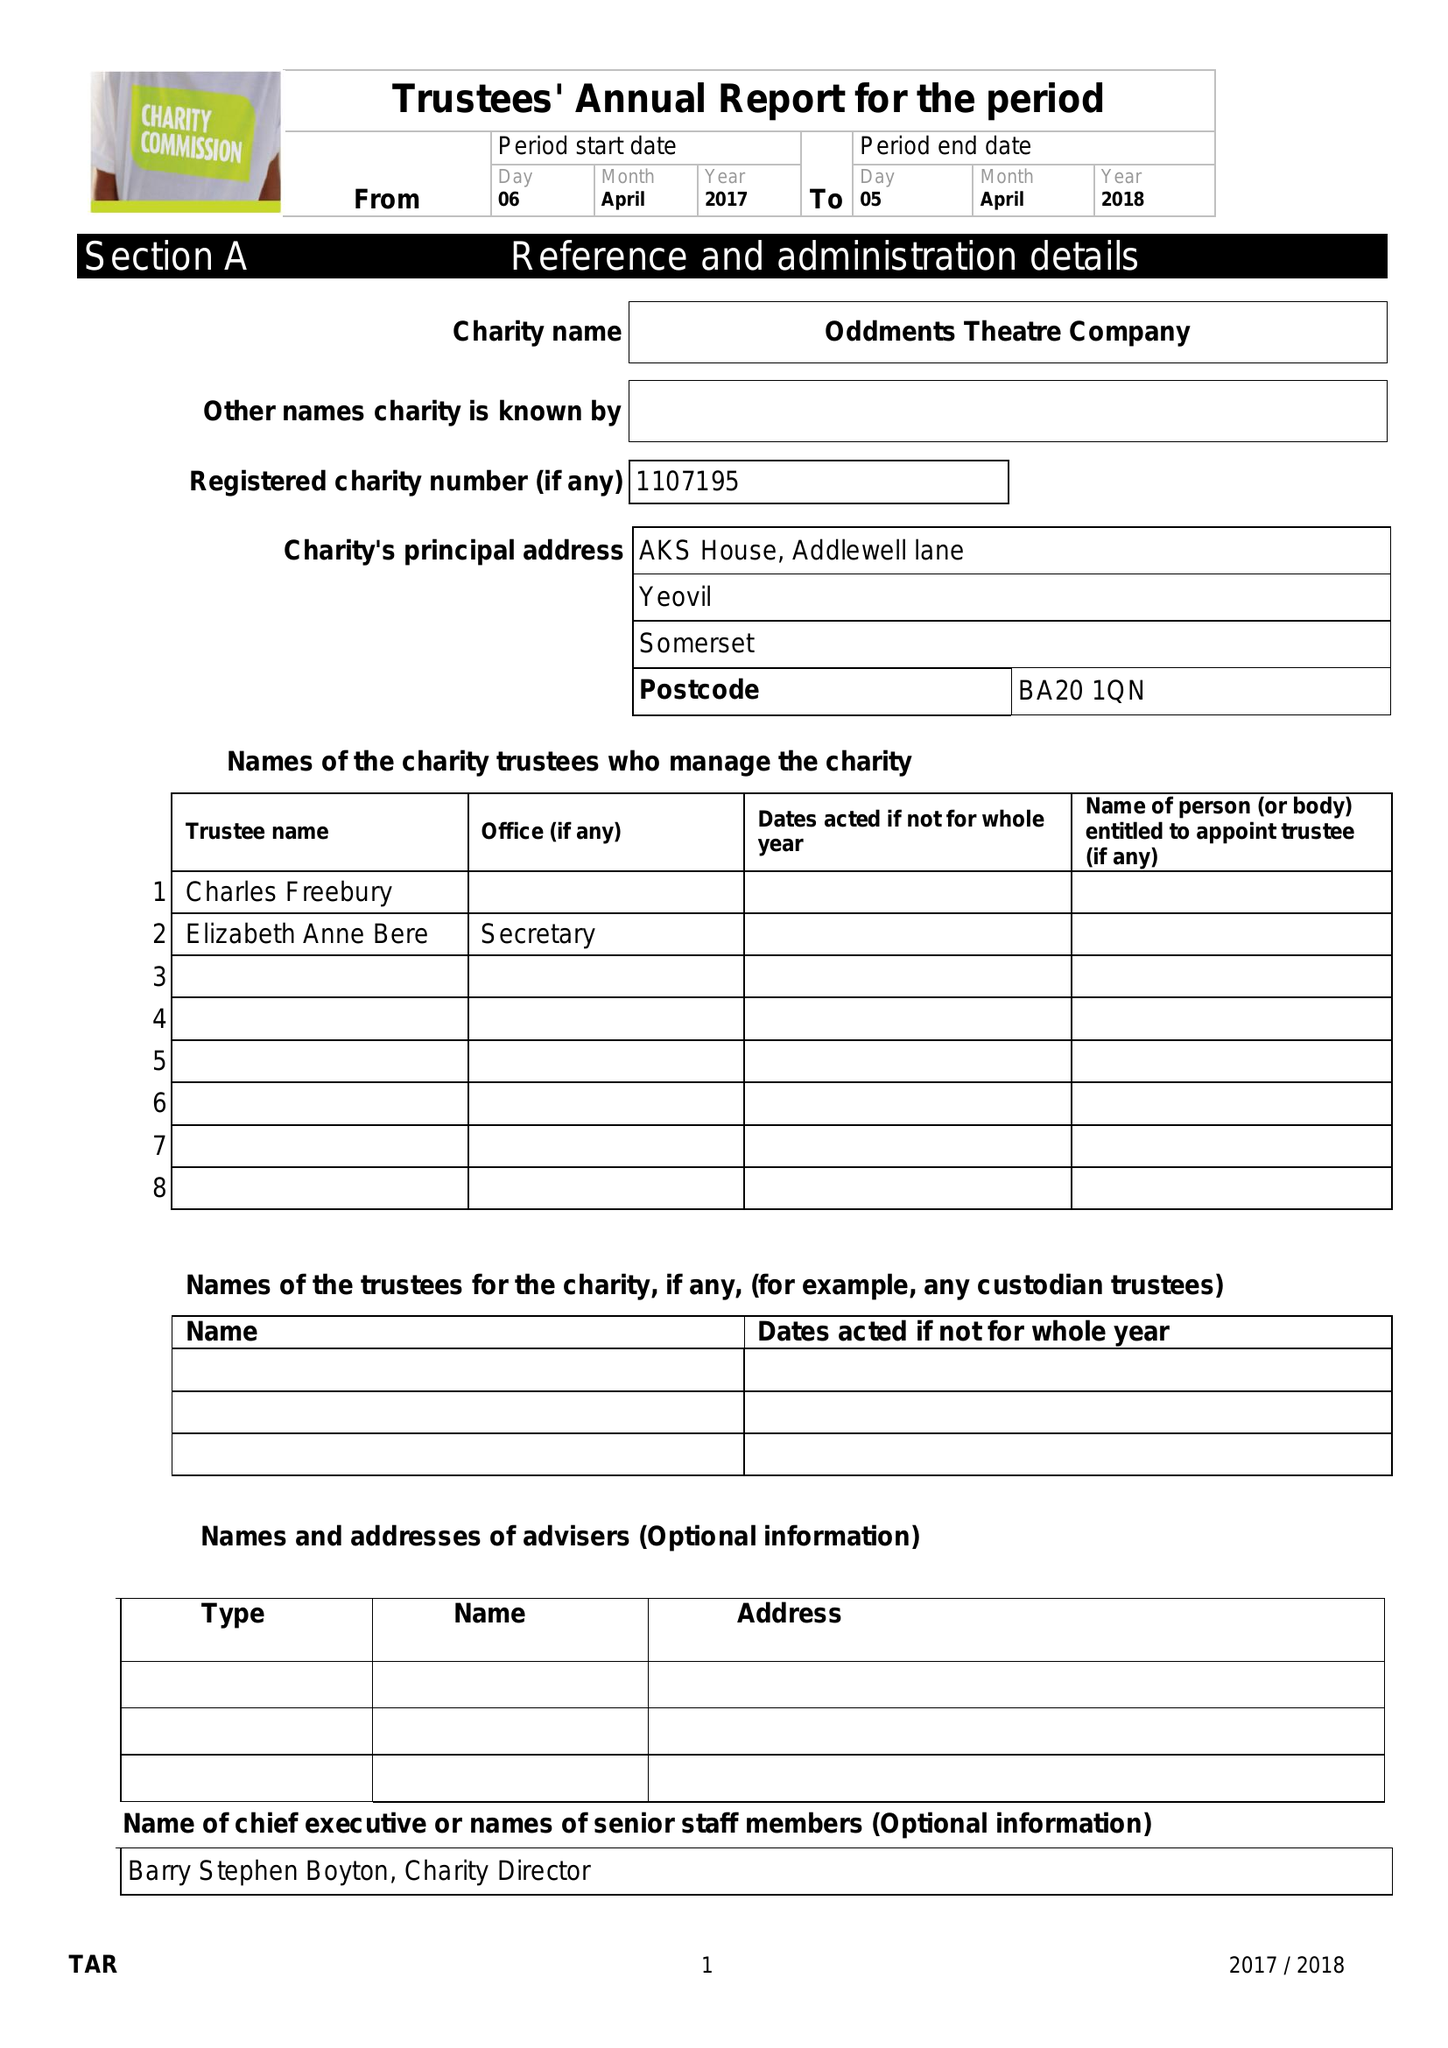What is the value for the address__street_line?
Answer the question using a single word or phrase. ADDLEWELL LANE 